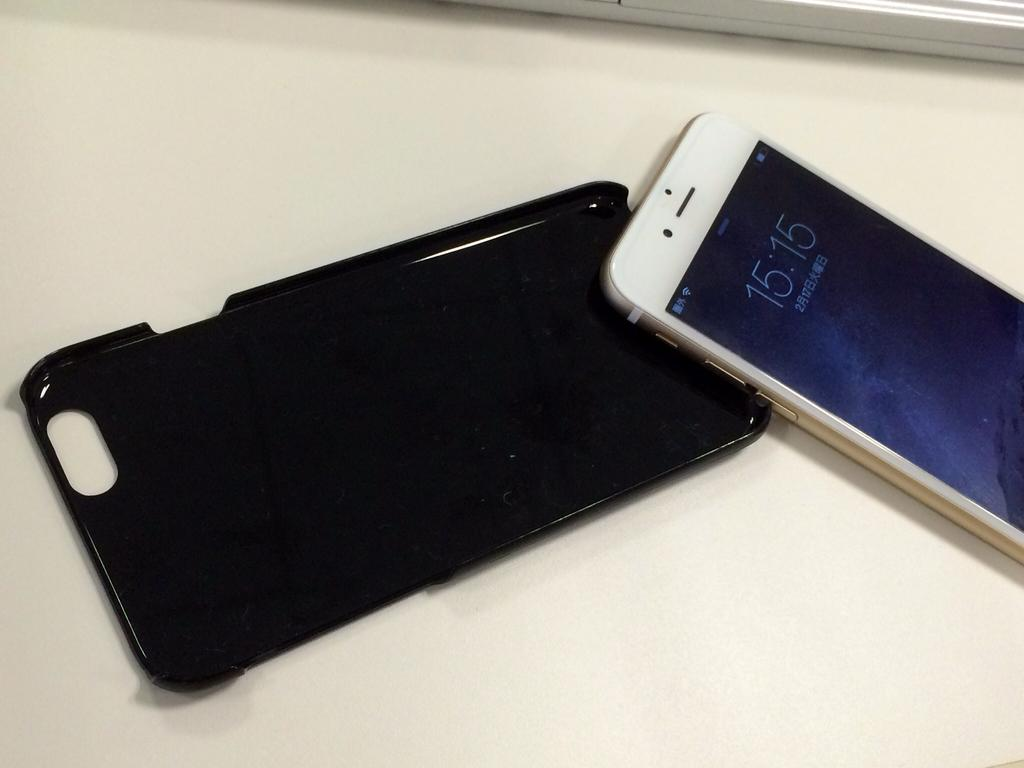<image>
Relay a brief, clear account of the picture shown. A white iPhone detached from its case shows the time at 15:15. 